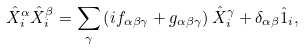<formula> <loc_0><loc_0><loc_500><loc_500>\hat { X } _ { i } ^ { \alpha } \hat { X } _ { i } ^ { \beta } = \sum _ { \gamma } \left ( i f _ { \alpha \beta \gamma } + g _ { \alpha \beta \gamma } \right ) \hat { X } _ { i } ^ { \gamma } + \delta _ { \alpha \beta } \hat { 1 } _ { i } ,</formula> 